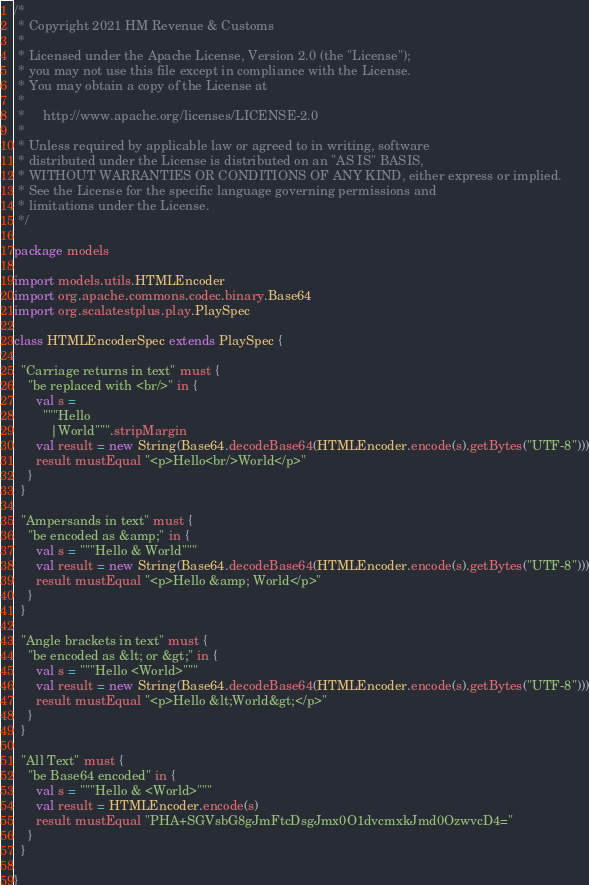Convert code to text. <code><loc_0><loc_0><loc_500><loc_500><_Scala_>/*
 * Copyright 2021 HM Revenue & Customs
 *
 * Licensed under the Apache License, Version 2.0 (the "License");
 * you may not use this file except in compliance with the License.
 * You may obtain a copy of the License at
 *
 *     http://www.apache.org/licenses/LICENSE-2.0
 *
 * Unless required by applicable law or agreed to in writing, software
 * distributed under the License is distributed on an "AS IS" BASIS,
 * WITHOUT WARRANTIES OR CONDITIONS OF ANY KIND, either express or implied.
 * See the License for the specific language governing permissions and
 * limitations under the License.
 */

package models

import models.utils.HTMLEncoder
import org.apache.commons.codec.binary.Base64
import org.scalatestplus.play.PlaySpec

class HTMLEncoderSpec extends PlaySpec {

  "Carriage returns in text" must {
    "be replaced with <br/>" in {
      val s =
        """Hello
          |World""".stripMargin
      val result = new String(Base64.decodeBase64(HTMLEncoder.encode(s).getBytes("UTF-8")))
      result mustEqual "<p>Hello<br/>World</p>"
    }
  }

  "Ampersands in text" must {
    "be encoded as &amp;" in {
      val s = """Hello & World"""
      val result = new String(Base64.decodeBase64(HTMLEncoder.encode(s).getBytes("UTF-8")))
      result mustEqual "<p>Hello &amp; World</p>"
    }
  }

  "Angle brackets in text" must {
    "be encoded as &lt; or &gt;" in {
      val s = """Hello <World>"""
      val result = new String(Base64.decodeBase64(HTMLEncoder.encode(s).getBytes("UTF-8")))
      result mustEqual "<p>Hello &lt;World&gt;</p>"
    }
  }

  "All Text" must {
    "be Base64 encoded" in {
      val s = """Hello & <World>"""
      val result = HTMLEncoder.encode(s)
      result mustEqual "PHA+SGVsbG8gJmFtcDsgJmx0O1dvcmxkJmd0OzwvcD4="
    }
  }

}
</code> 